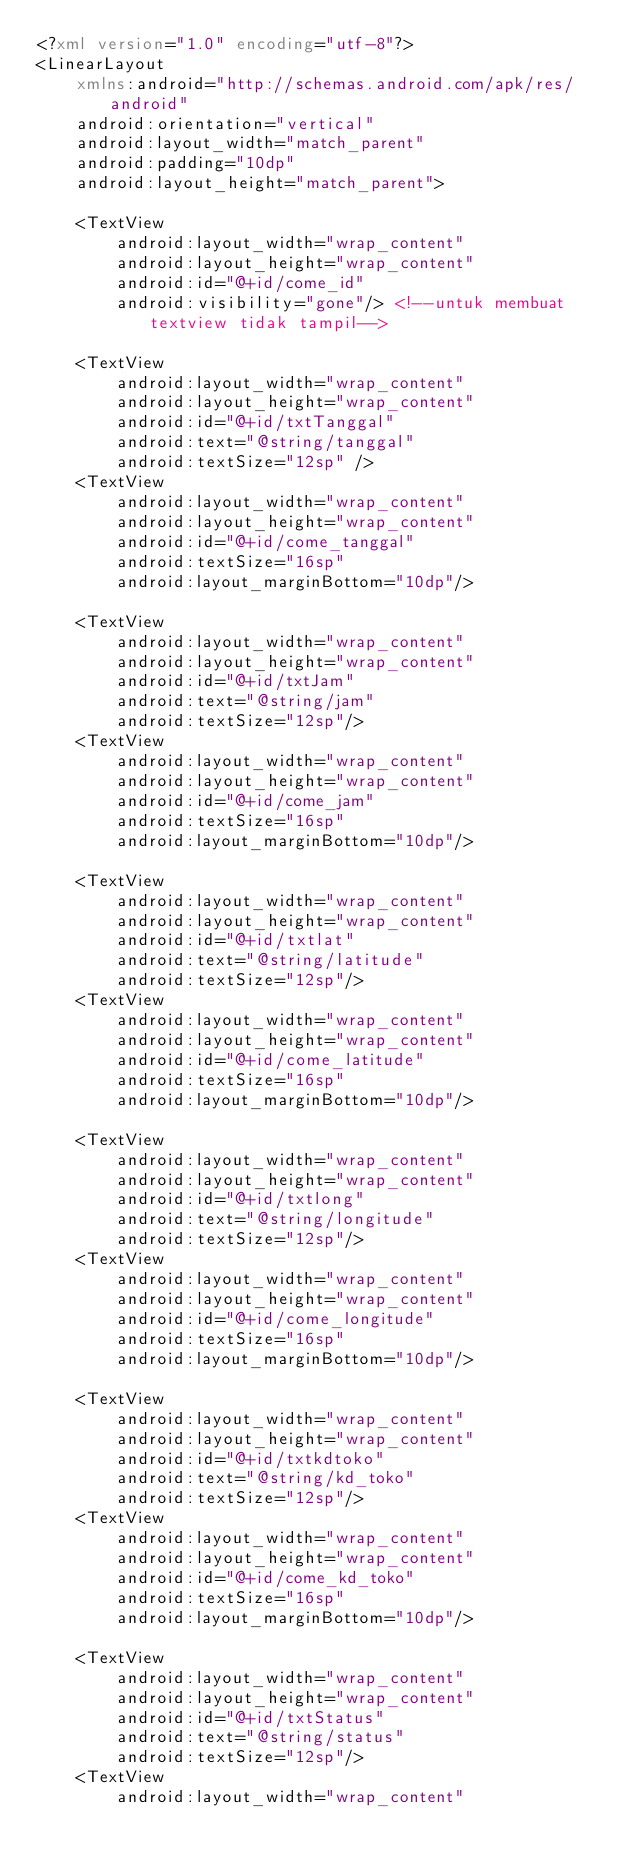Convert code to text. <code><loc_0><loc_0><loc_500><loc_500><_XML_><?xml version="1.0" encoding="utf-8"?>
<LinearLayout
    xmlns:android="http://schemas.android.com/apk/res/android"
    android:orientation="vertical"
    android:layout_width="match_parent"
    android:padding="10dp"
    android:layout_height="match_parent">

    <TextView
        android:layout_width="wrap_content"
        android:layout_height="wrap_content"
        android:id="@+id/come_id"
        android:visibility="gone"/> <!--untuk membuat textview tidak tampil-->

    <TextView
        android:layout_width="wrap_content"
        android:layout_height="wrap_content"
        android:id="@+id/txtTanggal"
        android:text="@string/tanggal"
        android:textSize="12sp" />
    <TextView
        android:layout_width="wrap_content"
        android:layout_height="wrap_content"
        android:id="@+id/come_tanggal"
        android:textSize="16sp"
        android:layout_marginBottom="10dp"/>

    <TextView
        android:layout_width="wrap_content"
        android:layout_height="wrap_content"
        android:id="@+id/txtJam"
        android:text="@string/jam"
        android:textSize="12sp"/>
    <TextView
        android:layout_width="wrap_content"
        android:layout_height="wrap_content"
        android:id="@+id/come_jam"
        android:textSize="16sp"
        android:layout_marginBottom="10dp"/>

    <TextView
        android:layout_width="wrap_content"
        android:layout_height="wrap_content"
        android:id="@+id/txtlat"
        android:text="@string/latitude"
        android:textSize="12sp"/>
    <TextView
        android:layout_width="wrap_content"
        android:layout_height="wrap_content"
        android:id="@+id/come_latitude"
        android:textSize="16sp"
        android:layout_marginBottom="10dp"/>

    <TextView
        android:layout_width="wrap_content"
        android:layout_height="wrap_content"
        android:id="@+id/txtlong"
        android:text="@string/longitude"
        android:textSize="12sp"/>
    <TextView
        android:layout_width="wrap_content"
        android:layout_height="wrap_content"
        android:id="@+id/come_longitude"
        android:textSize="16sp"
        android:layout_marginBottom="10dp"/>

    <TextView
        android:layout_width="wrap_content"
        android:layout_height="wrap_content"
        android:id="@+id/txtkdtoko"
        android:text="@string/kd_toko"
        android:textSize="12sp"/>
    <TextView
        android:layout_width="wrap_content"
        android:layout_height="wrap_content"
        android:id="@+id/come_kd_toko"
        android:textSize="16sp"
        android:layout_marginBottom="10dp"/>

    <TextView
        android:layout_width="wrap_content"
        android:layout_height="wrap_content"
        android:id="@+id/txtStatus"
        android:text="@string/status"
        android:textSize="12sp"/>
    <TextView
        android:layout_width="wrap_content"</code> 